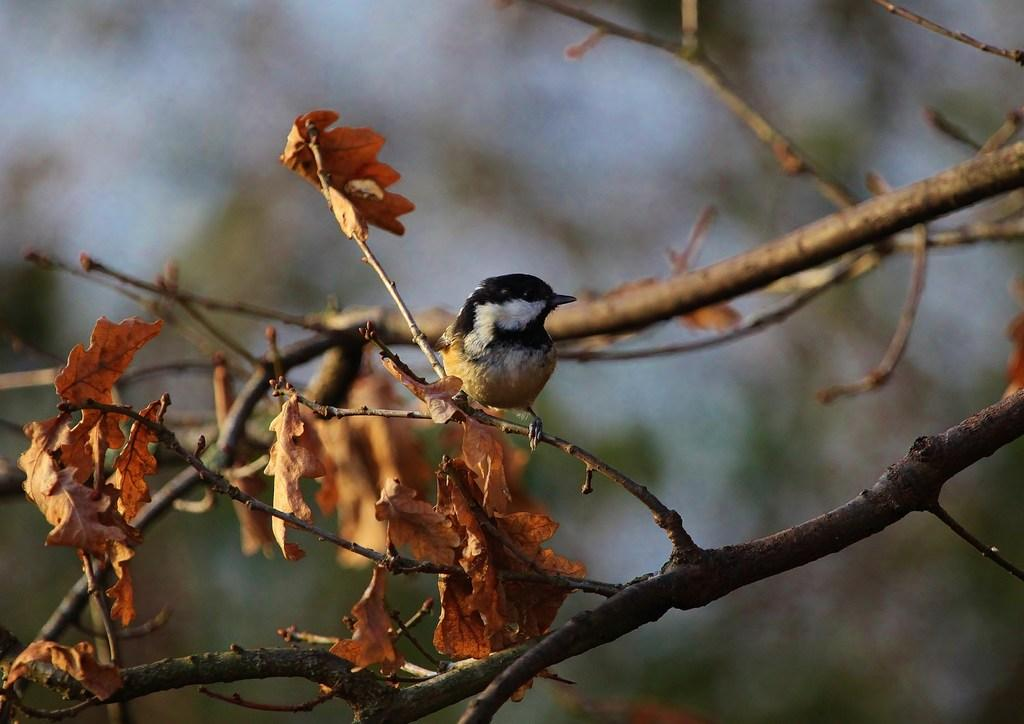What type of animal can be seen in the image? There is a bird in the image. What is the bird perched on in the image? The bird is perched on branches in the image. What else can be seen on the branches? There are leaves on the branches in the image. How would you describe the background of the image? The background of the image is blurred. What type of agreement is being signed by the bird in the image? There is no agreement being signed in the image; it features a bird perched on branches with leaves. 